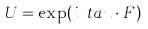Convert formula to latex. <formula><loc_0><loc_0><loc_500><loc_500>U = \exp ( i \boldmath \ t a u \cdot F )</formula> 